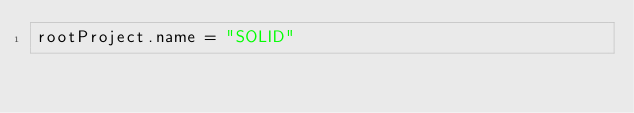<code> <loc_0><loc_0><loc_500><loc_500><_Kotlin_>rootProject.name = "SOLID"

</code> 